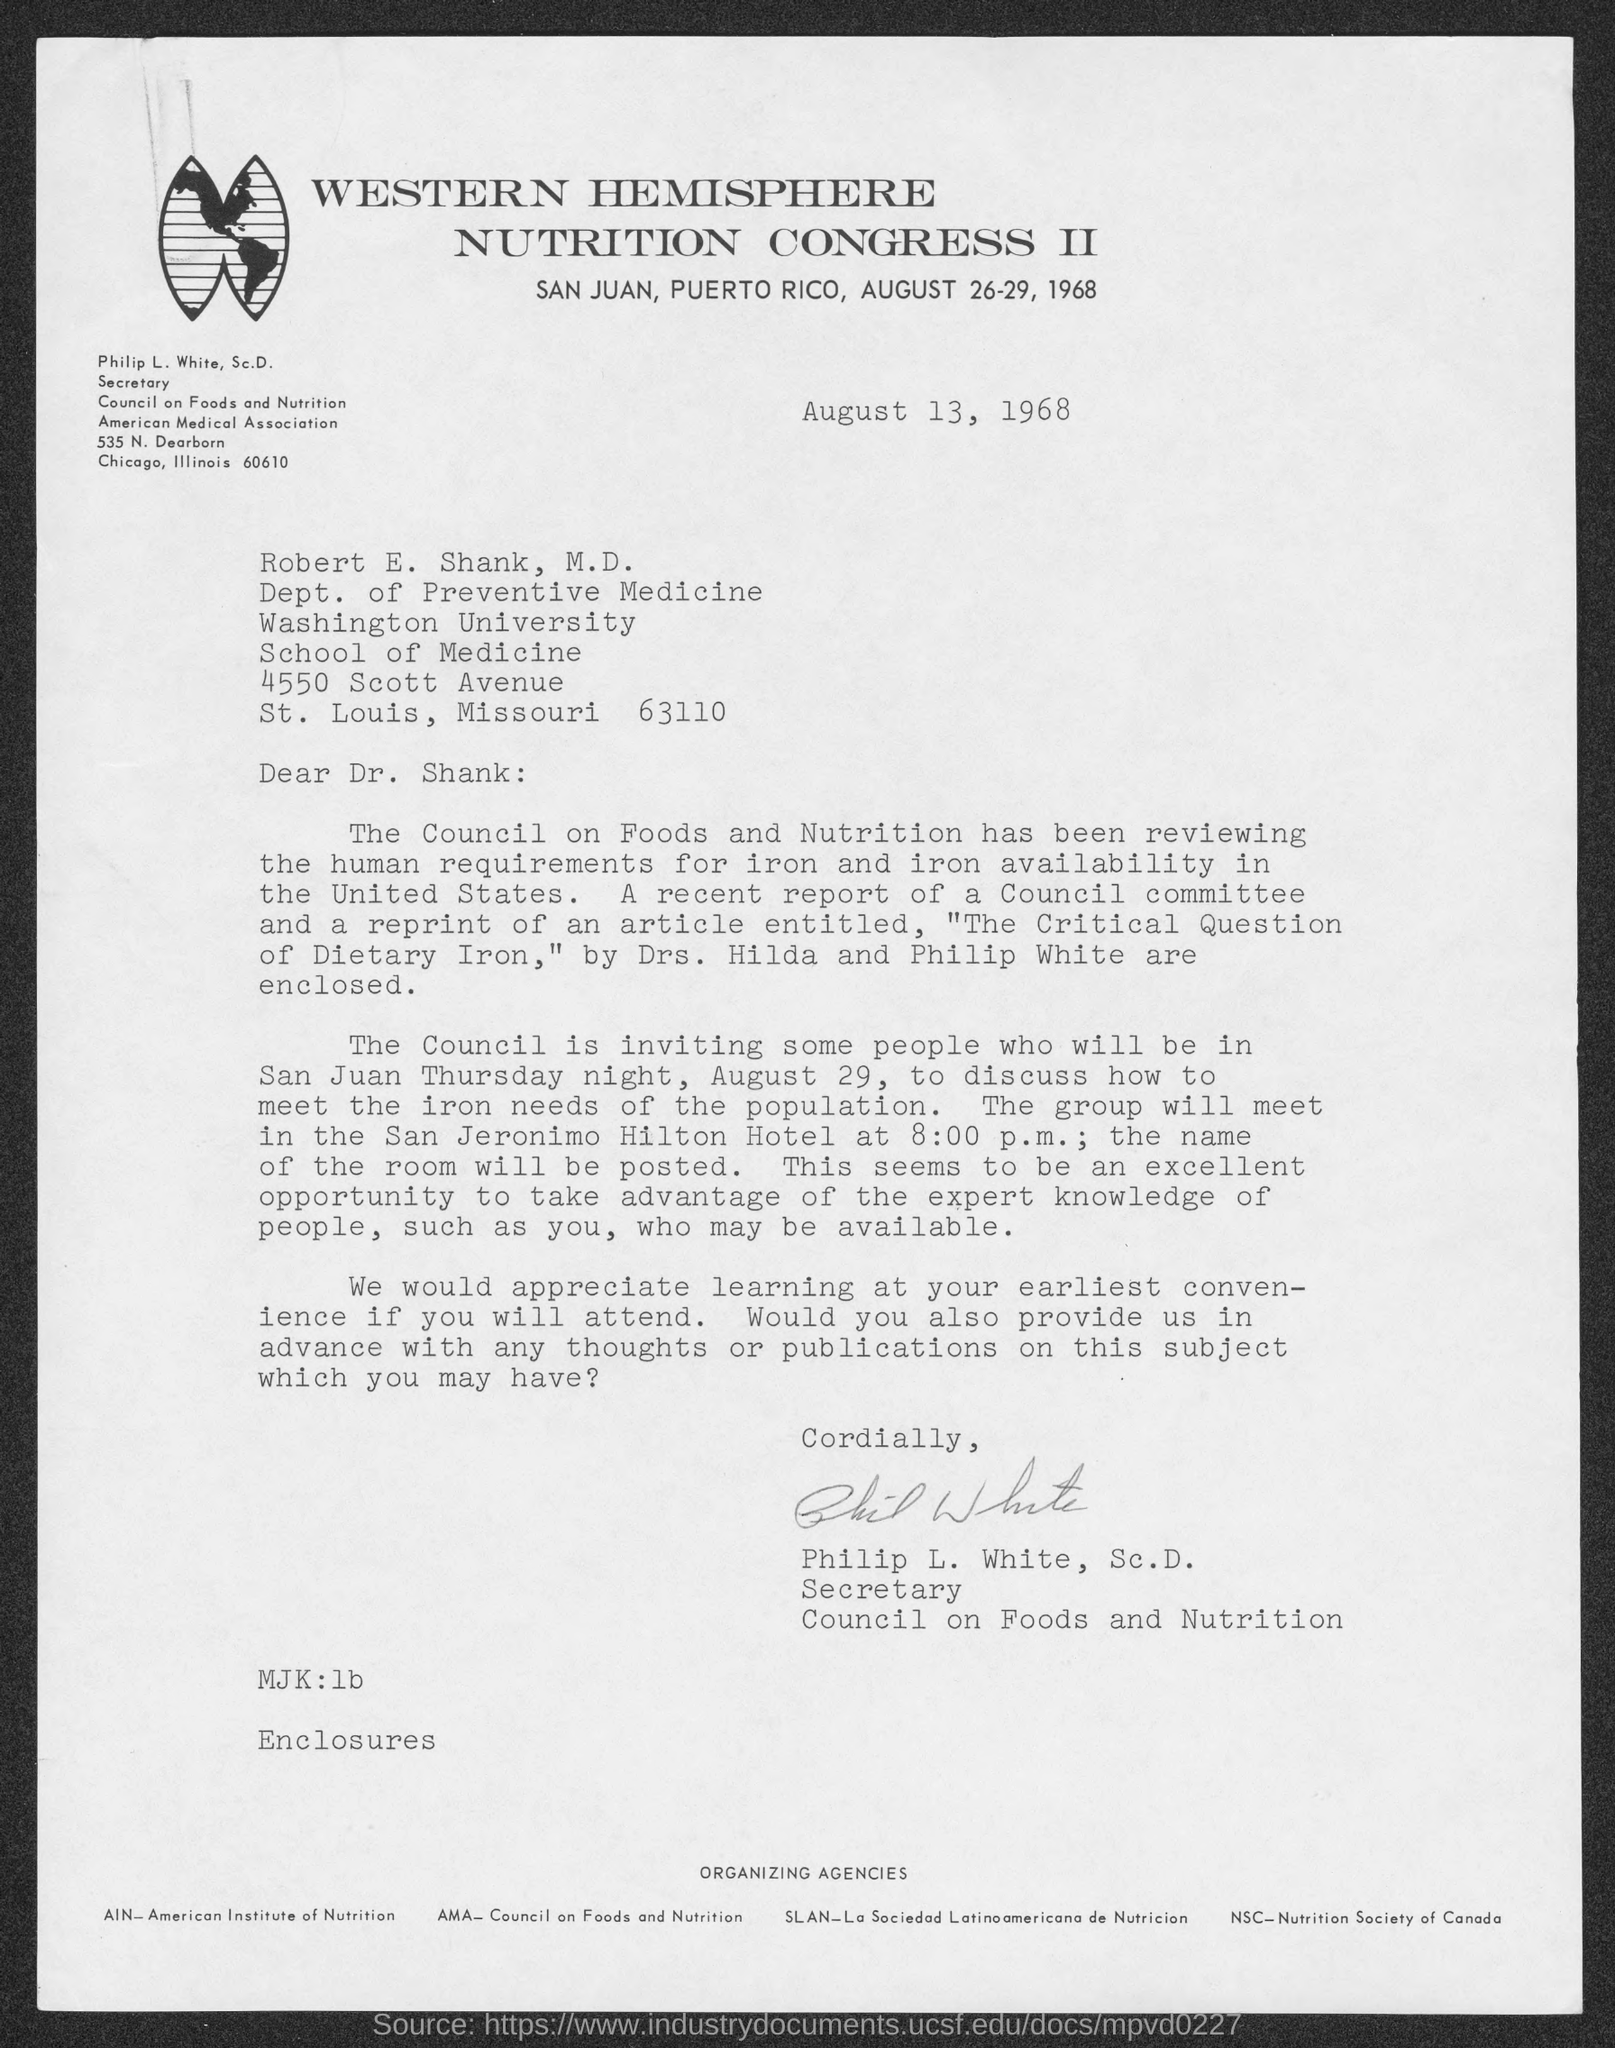To whom is the letter sent ?
Provide a short and direct response. ROBERT E. SHANK. Who wrote the letter?
Provide a succinct answer. PHILIP L. WHITE. 